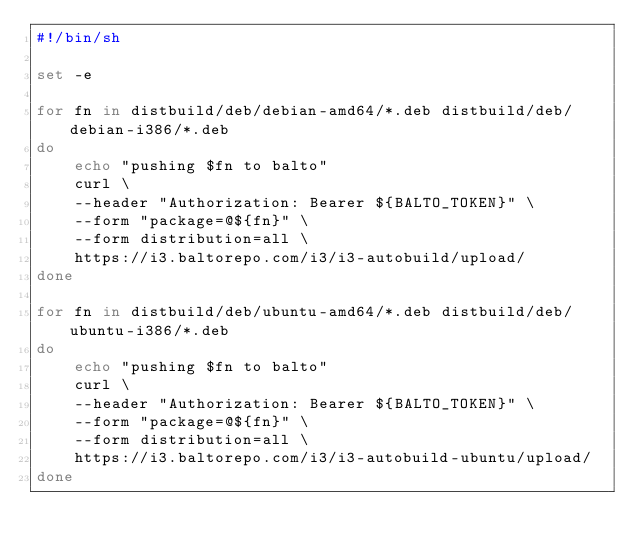<code> <loc_0><loc_0><loc_500><loc_500><_Bash_>#!/bin/sh

set -e

for fn in distbuild/deb/debian-amd64/*.deb distbuild/deb/debian-i386/*.deb
do
    echo "pushing $fn to balto"
    curl \
	--header "Authorization: Bearer ${BALTO_TOKEN}" \
	--form "package=@${fn}" \
	--form distribution=all \
	https://i3.baltorepo.com/i3/i3-autobuild/upload/
done

for fn in distbuild/deb/ubuntu-amd64/*.deb distbuild/deb/ubuntu-i386/*.deb
do
    echo "pushing $fn to balto"
    curl \
	--header "Authorization: Bearer ${BALTO_TOKEN}" \
	--form "package=@${fn}" \
	--form distribution=all \
	https://i3.baltorepo.com/i3/i3-autobuild-ubuntu/upload/
done
</code> 